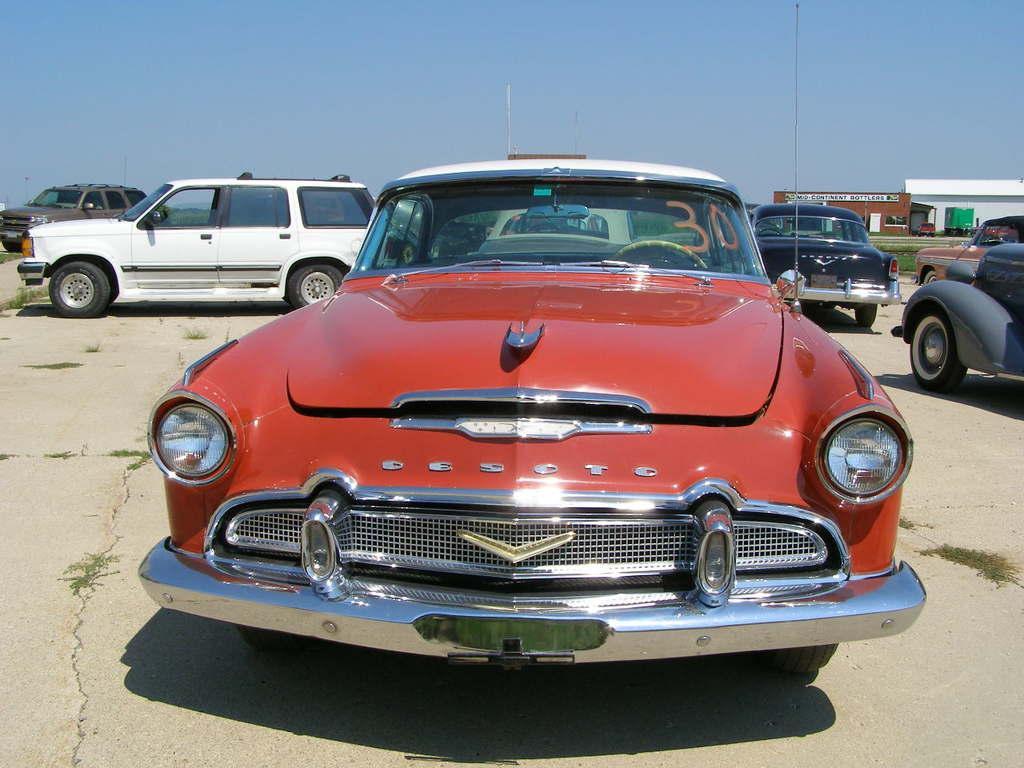In one or two sentences, can you explain what this image depicts? In the center of the image we can see cars. On the right there is a building. In the background we can see sky. 